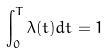<formula> <loc_0><loc_0><loc_500><loc_500>\int _ { 0 } ^ { T } \lambda ( t ) d t = 1</formula> 